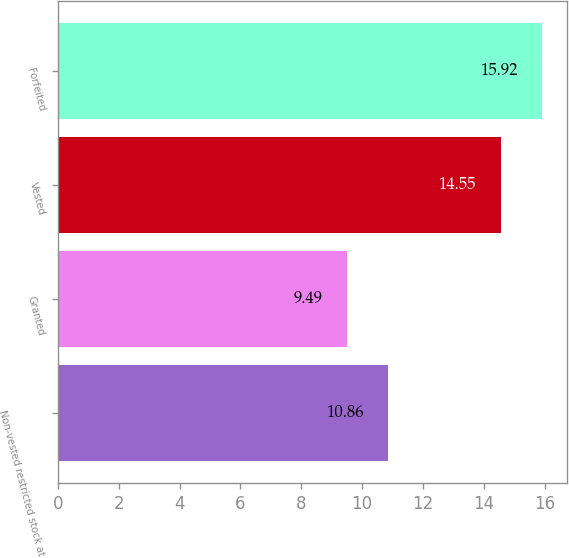Convert chart to OTSL. <chart><loc_0><loc_0><loc_500><loc_500><bar_chart><fcel>Non-vested restricted stock at<fcel>Granted<fcel>Vested<fcel>Forfeited<nl><fcel>10.86<fcel>9.49<fcel>14.55<fcel>15.92<nl></chart> 